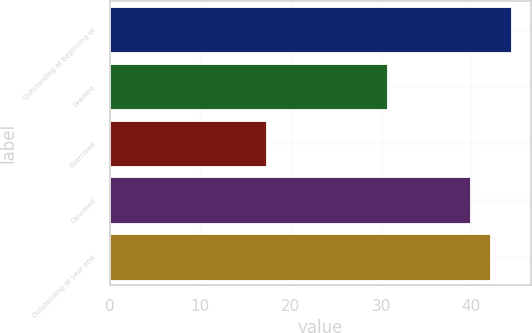Convert chart. <chart><loc_0><loc_0><loc_500><loc_500><bar_chart><fcel>Outstanding at beginning of<fcel>Granted<fcel>Exercised<fcel>Canceled<fcel>Outstanding at year end<nl><fcel>44.42<fcel>30.7<fcel>17.28<fcel>39.8<fcel>42.11<nl></chart> 